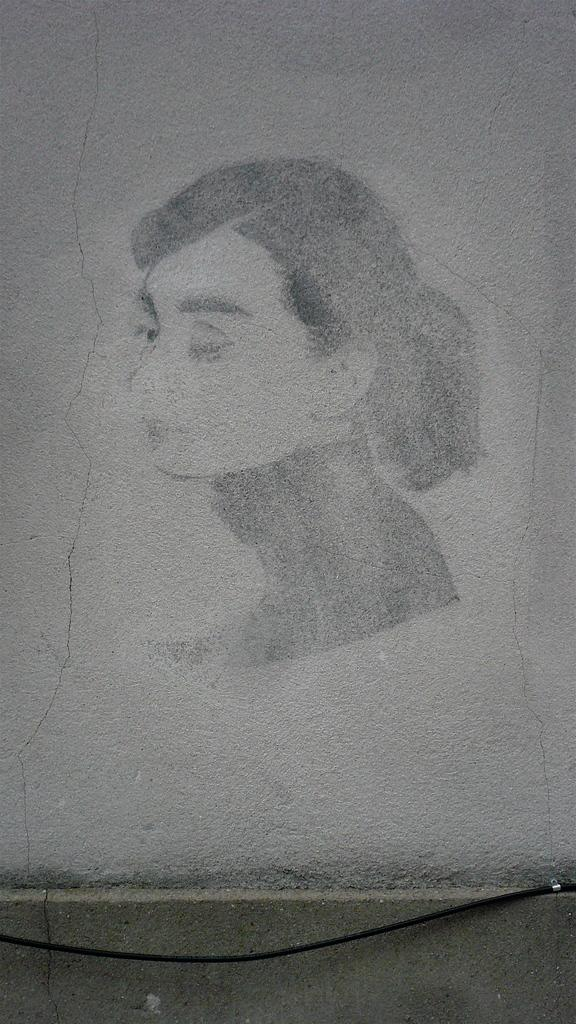What is depicted in the image? There is a sketch of a lady person in the image. What type of drink is the lady person holding in the image? There is no drink present in the image, as it is a sketch of a lady person and not a photograph or scene with objects. 